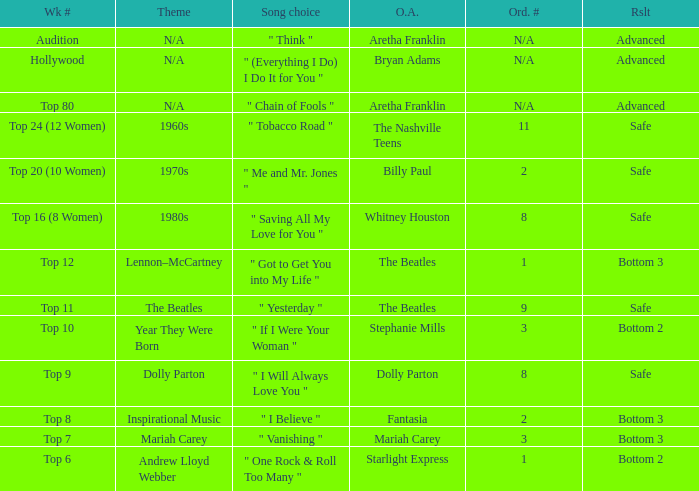Name the song choice when week number is hollywood " (Everything I Do) I Do It for You ". 